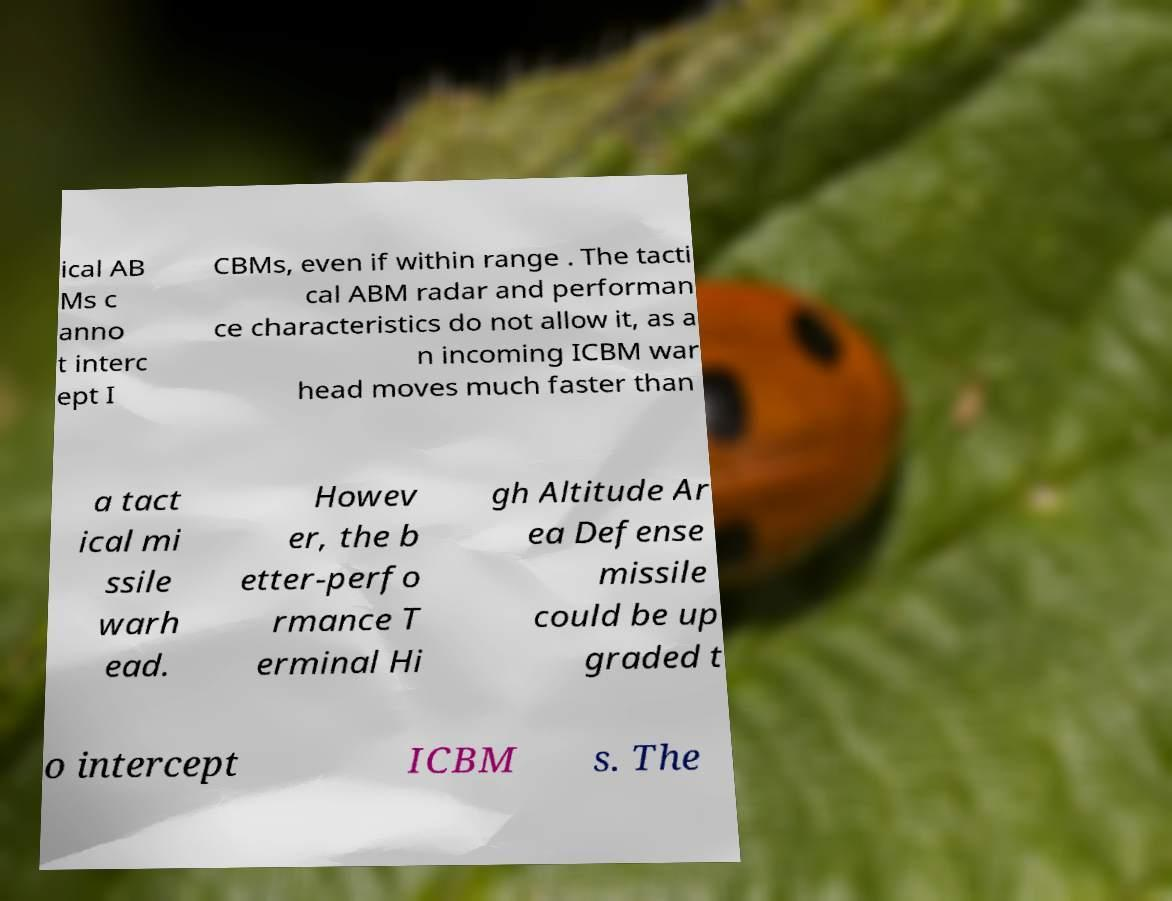Please read and relay the text visible in this image. What does it say? ical AB Ms c anno t interc ept I CBMs, even if within range . The tacti cal ABM radar and performan ce characteristics do not allow it, as a n incoming ICBM war head moves much faster than a tact ical mi ssile warh ead. Howev er, the b etter-perfo rmance T erminal Hi gh Altitude Ar ea Defense missile could be up graded t o intercept ICBM s. The 